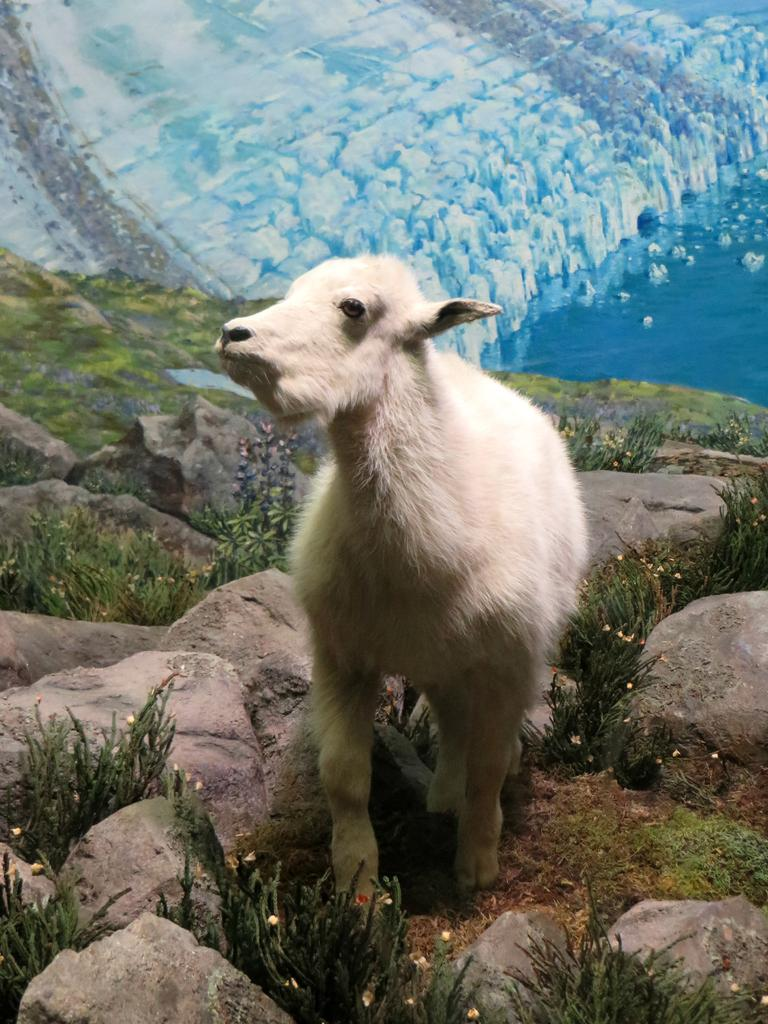What type of surface can be seen in the image? Ground is visible in the image. What is covering the ground? Grass and stones are present on the ground. What color is the animal in the image? There is a white-colored animal in the image. What can be seen in the background of the image? There is a depiction or picture visible in the background. Where is the nearest shop to buy juice in the image? There is no reference to a shop or juice in the image, so it's not possible to determine the location of a shop selling juice. 